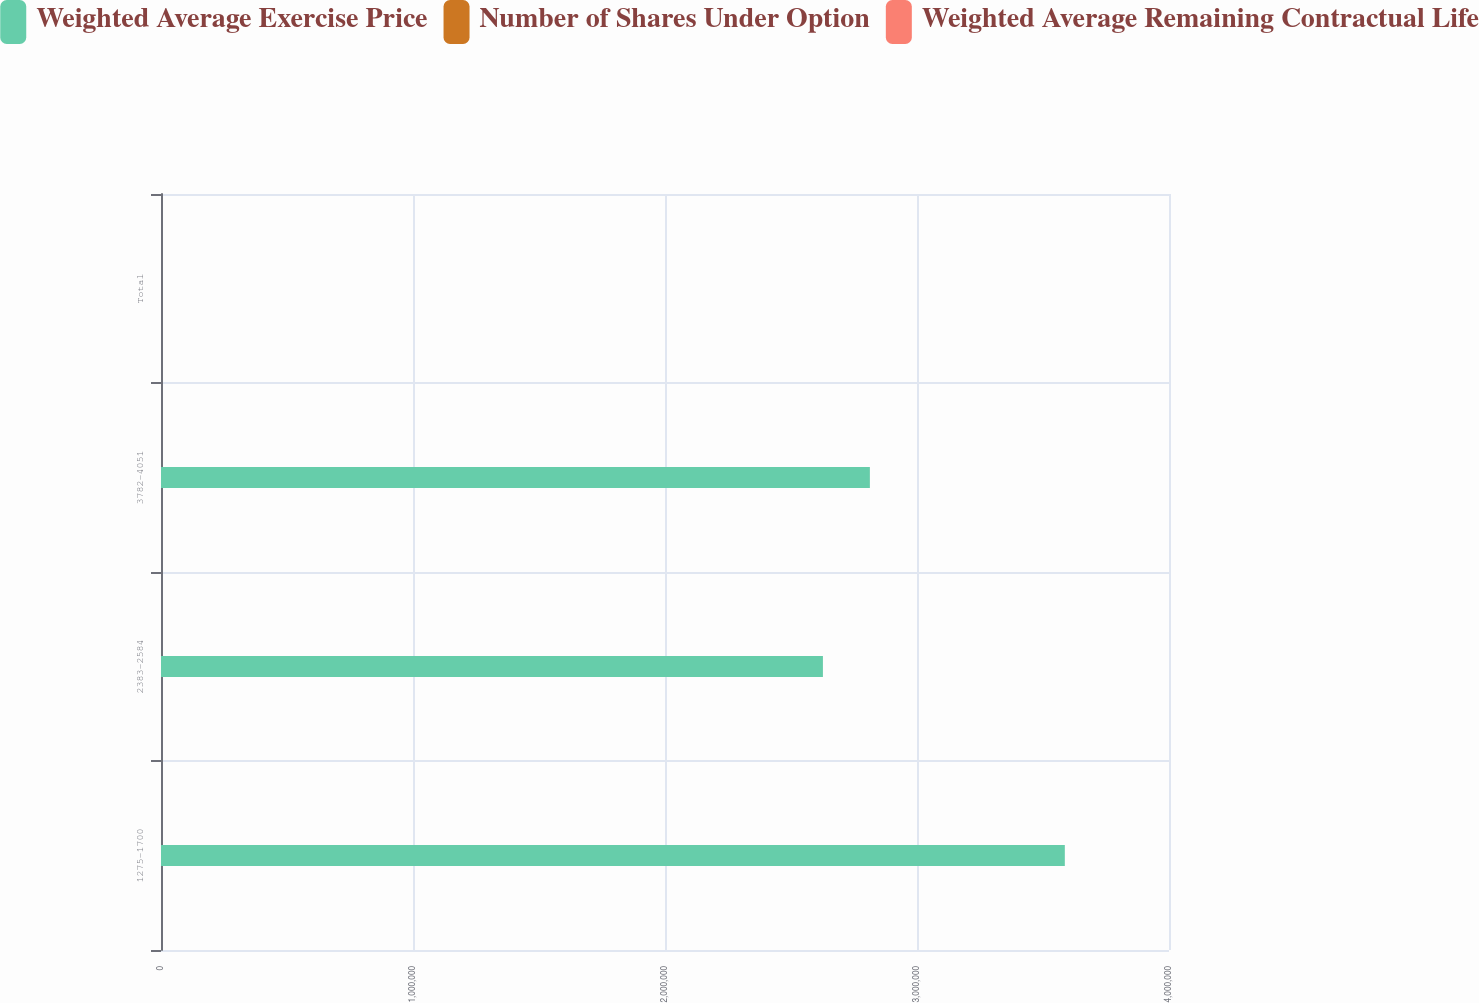Convert chart to OTSL. <chart><loc_0><loc_0><loc_500><loc_500><stacked_bar_chart><ecel><fcel>1275-1700<fcel>2383-2584<fcel>3782-4051<fcel>Total<nl><fcel>Weighted Average Exercise Price<fcel>3.58661e+06<fcel>2.62664e+06<fcel>2.81298e+06<fcel>24.98<nl><fcel>Number of Shares Under Option<fcel>6<fcel>7<fcel>8<fcel>8<nl><fcel>Weighted Average Remaining Contractual Life<fcel>15.61<fcel>24.98<fcel>37.84<fcel>34.58<nl></chart> 